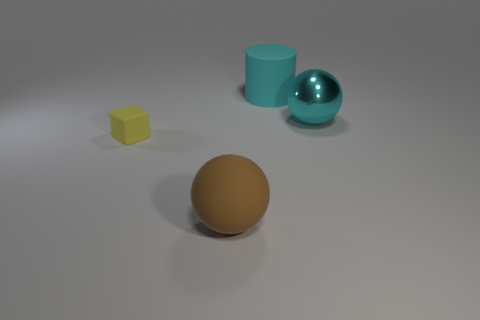Is there anything else that is the same shape as the yellow matte thing?
Offer a very short reply. No. Are there more yellow things that are behind the big shiny sphere than brown objects that are in front of the large brown object?
Ensure brevity in your answer.  No. There is a ball that is to the right of the big thing in front of the big sphere on the right side of the brown ball; how big is it?
Your answer should be compact. Large. Is the large cyan sphere made of the same material as the thing in front of the yellow thing?
Offer a terse response. No. Do the cyan shiny object and the small rubber thing have the same shape?
Ensure brevity in your answer.  No. How many other objects are the same material as the big cyan cylinder?
Provide a succinct answer. 2. How many other things are the same shape as the large cyan shiny object?
Give a very brief answer. 1. There is a object that is in front of the large cyan metal thing and behind the matte ball; what is its color?
Offer a terse response. Yellow. How many large yellow rubber cubes are there?
Your response must be concise. 0. Is the brown ball the same size as the cyan ball?
Provide a short and direct response. Yes. 